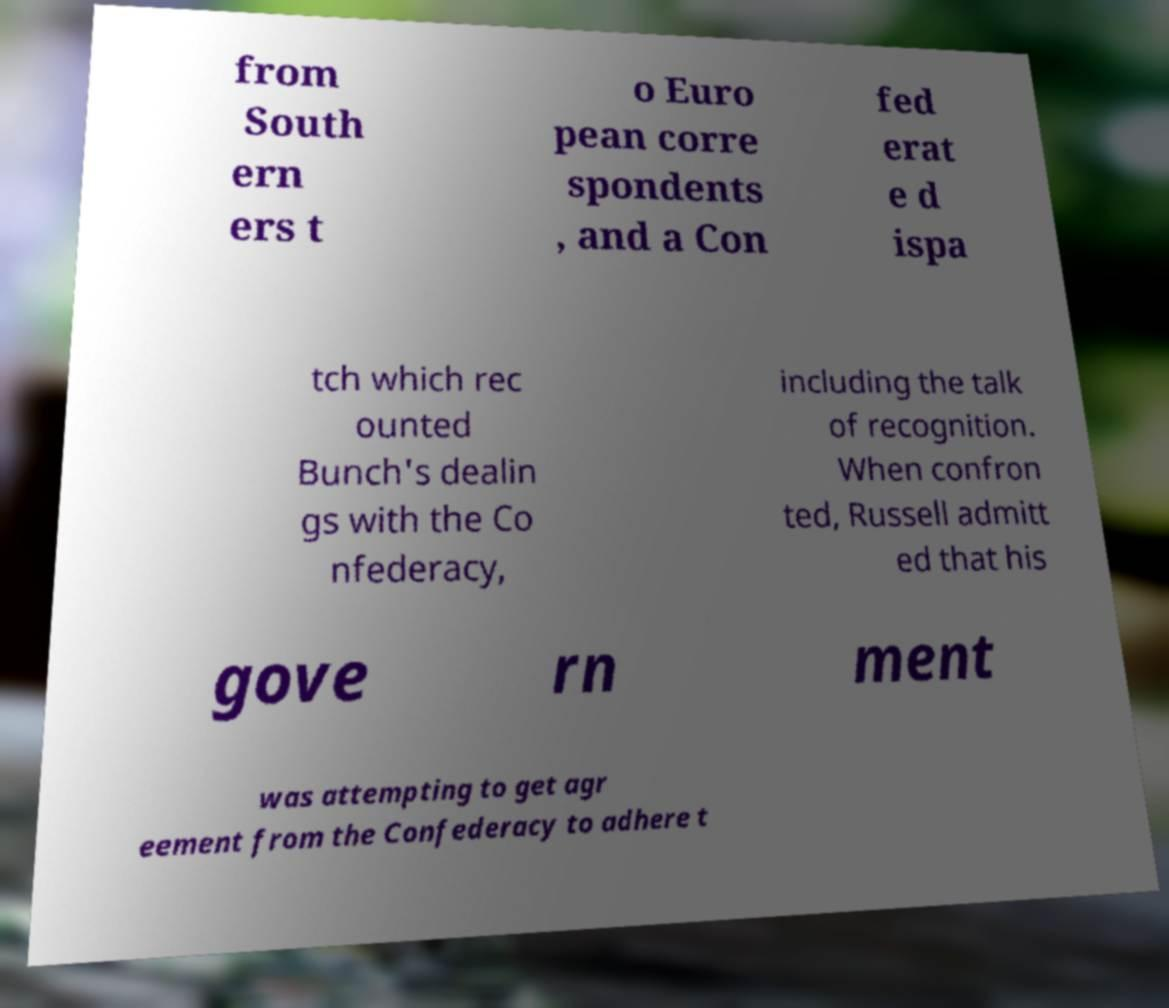Could you assist in decoding the text presented in this image and type it out clearly? from South ern ers t o Euro pean corre spondents , and a Con fed erat e d ispa tch which rec ounted Bunch's dealin gs with the Co nfederacy, including the talk of recognition. When confron ted, Russell admitt ed that his gove rn ment was attempting to get agr eement from the Confederacy to adhere t 